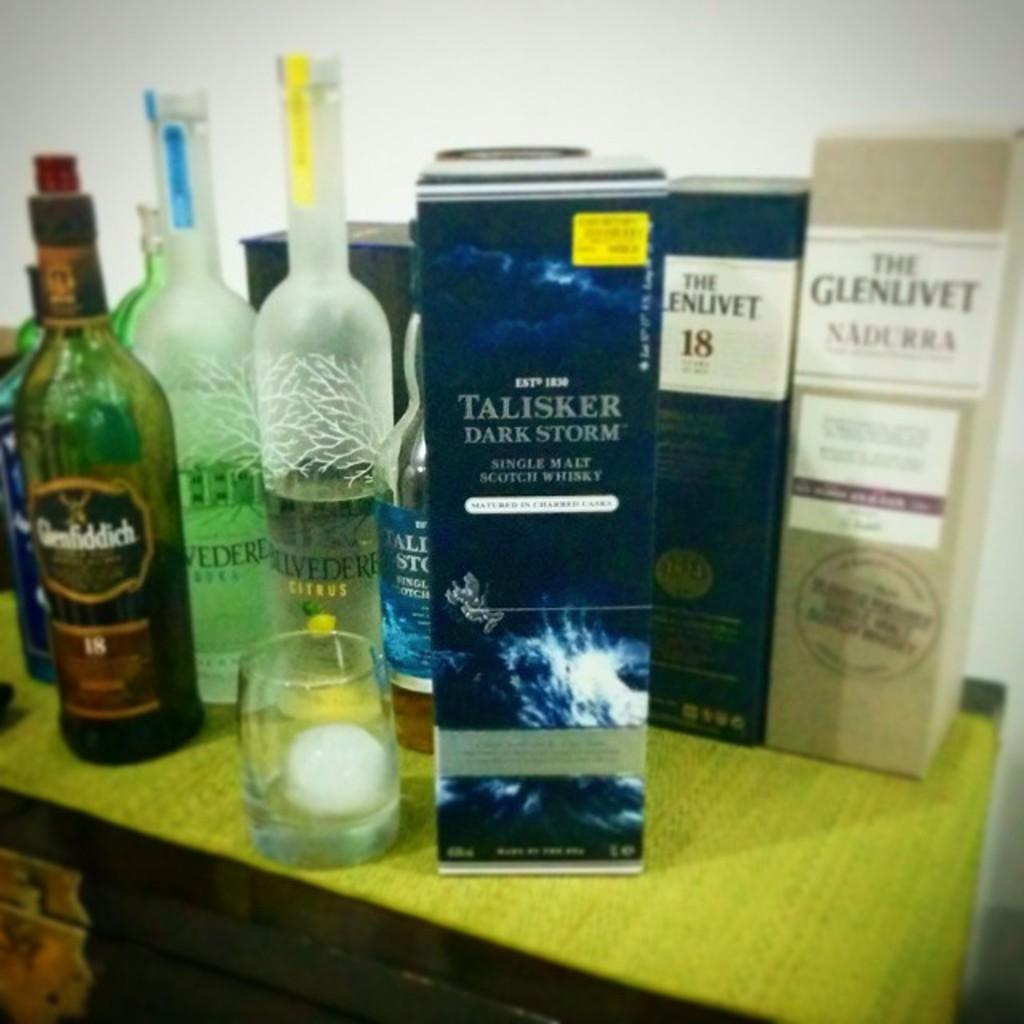<image>
Describe the image concisely. A box marked Talisker Dark Storm single malt scotch whisky is on a table amongst other liquor. 